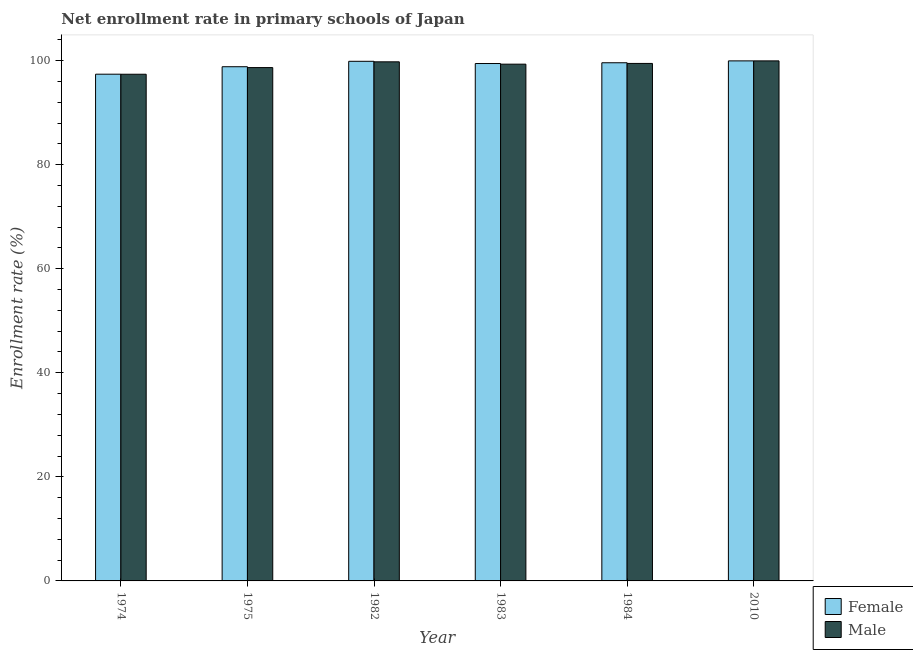How many different coloured bars are there?
Give a very brief answer. 2. How many groups of bars are there?
Ensure brevity in your answer.  6. Are the number of bars per tick equal to the number of legend labels?
Your answer should be very brief. Yes. Are the number of bars on each tick of the X-axis equal?
Your answer should be very brief. Yes. How many bars are there on the 2nd tick from the right?
Ensure brevity in your answer.  2. In how many cases, is the number of bars for a given year not equal to the number of legend labels?
Provide a short and direct response. 0. What is the enrollment rate of male students in 2010?
Your response must be concise. 99.95. Across all years, what is the maximum enrollment rate of female students?
Offer a very short reply. 99.95. Across all years, what is the minimum enrollment rate of male students?
Make the answer very short. 97.38. In which year was the enrollment rate of male students maximum?
Provide a short and direct response. 2010. In which year was the enrollment rate of female students minimum?
Offer a very short reply. 1974. What is the total enrollment rate of male students in the graph?
Make the answer very short. 594.53. What is the difference between the enrollment rate of female students in 1974 and that in 2010?
Your answer should be very brief. -2.56. What is the difference between the enrollment rate of female students in 1974 and the enrollment rate of male students in 1982?
Your answer should be compact. -2.48. What is the average enrollment rate of male students per year?
Give a very brief answer. 99.09. In the year 1983, what is the difference between the enrollment rate of male students and enrollment rate of female students?
Your response must be concise. 0. What is the ratio of the enrollment rate of male students in 1983 to that in 2010?
Give a very brief answer. 0.99. Is the enrollment rate of female students in 1982 less than that in 1984?
Your answer should be compact. No. What is the difference between the highest and the second highest enrollment rate of female students?
Keep it short and to the point. 0.08. What is the difference between the highest and the lowest enrollment rate of male students?
Make the answer very short. 2.57. In how many years, is the enrollment rate of female students greater than the average enrollment rate of female students taken over all years?
Offer a very short reply. 4. Is the sum of the enrollment rate of male students in 1975 and 1984 greater than the maximum enrollment rate of female students across all years?
Offer a terse response. Yes. What does the 2nd bar from the right in 1974 represents?
Your response must be concise. Female. Are all the bars in the graph horizontal?
Offer a very short reply. No. How many years are there in the graph?
Your answer should be compact. 6. What is the difference between two consecutive major ticks on the Y-axis?
Provide a succinct answer. 20. What is the title of the graph?
Your answer should be very brief. Net enrollment rate in primary schools of Japan. What is the label or title of the X-axis?
Your answer should be very brief. Year. What is the label or title of the Y-axis?
Make the answer very short. Enrollment rate (%). What is the Enrollment rate (%) in Female in 1974?
Your answer should be very brief. 97.39. What is the Enrollment rate (%) of Male in 1974?
Offer a very short reply. 97.38. What is the Enrollment rate (%) in Female in 1975?
Keep it short and to the point. 98.82. What is the Enrollment rate (%) of Male in 1975?
Give a very brief answer. 98.66. What is the Enrollment rate (%) of Female in 1982?
Give a very brief answer. 99.87. What is the Enrollment rate (%) in Male in 1982?
Provide a succinct answer. 99.77. What is the Enrollment rate (%) in Female in 1983?
Provide a succinct answer. 99.44. What is the Enrollment rate (%) in Male in 1983?
Offer a very short reply. 99.32. What is the Enrollment rate (%) in Female in 1984?
Your response must be concise. 99.59. What is the Enrollment rate (%) of Male in 1984?
Keep it short and to the point. 99.46. What is the Enrollment rate (%) in Female in 2010?
Provide a succinct answer. 99.95. What is the Enrollment rate (%) in Male in 2010?
Give a very brief answer. 99.95. Across all years, what is the maximum Enrollment rate (%) in Female?
Your answer should be very brief. 99.95. Across all years, what is the maximum Enrollment rate (%) of Male?
Your answer should be compact. 99.95. Across all years, what is the minimum Enrollment rate (%) of Female?
Make the answer very short. 97.39. Across all years, what is the minimum Enrollment rate (%) in Male?
Provide a short and direct response. 97.38. What is the total Enrollment rate (%) in Female in the graph?
Your response must be concise. 595.06. What is the total Enrollment rate (%) of Male in the graph?
Offer a terse response. 594.53. What is the difference between the Enrollment rate (%) in Female in 1974 and that in 1975?
Offer a very short reply. -1.43. What is the difference between the Enrollment rate (%) of Male in 1974 and that in 1975?
Provide a succinct answer. -1.28. What is the difference between the Enrollment rate (%) in Female in 1974 and that in 1982?
Provide a succinct answer. -2.48. What is the difference between the Enrollment rate (%) of Male in 1974 and that in 1982?
Offer a terse response. -2.39. What is the difference between the Enrollment rate (%) in Female in 1974 and that in 1983?
Offer a terse response. -2.05. What is the difference between the Enrollment rate (%) in Male in 1974 and that in 1983?
Offer a very short reply. -1.94. What is the difference between the Enrollment rate (%) of Female in 1974 and that in 1984?
Your response must be concise. -2.2. What is the difference between the Enrollment rate (%) in Male in 1974 and that in 1984?
Provide a short and direct response. -2.08. What is the difference between the Enrollment rate (%) of Female in 1974 and that in 2010?
Your response must be concise. -2.56. What is the difference between the Enrollment rate (%) of Male in 1974 and that in 2010?
Keep it short and to the point. -2.57. What is the difference between the Enrollment rate (%) of Female in 1975 and that in 1982?
Your response must be concise. -1.04. What is the difference between the Enrollment rate (%) in Male in 1975 and that in 1982?
Keep it short and to the point. -1.11. What is the difference between the Enrollment rate (%) of Female in 1975 and that in 1983?
Offer a terse response. -0.62. What is the difference between the Enrollment rate (%) in Male in 1975 and that in 1983?
Make the answer very short. -0.66. What is the difference between the Enrollment rate (%) in Female in 1975 and that in 1984?
Offer a terse response. -0.76. What is the difference between the Enrollment rate (%) in Male in 1975 and that in 1984?
Ensure brevity in your answer.  -0.8. What is the difference between the Enrollment rate (%) in Female in 1975 and that in 2010?
Keep it short and to the point. -1.13. What is the difference between the Enrollment rate (%) of Male in 1975 and that in 2010?
Give a very brief answer. -1.29. What is the difference between the Enrollment rate (%) of Female in 1982 and that in 1983?
Offer a terse response. 0.43. What is the difference between the Enrollment rate (%) of Male in 1982 and that in 1983?
Your answer should be very brief. 0.45. What is the difference between the Enrollment rate (%) in Female in 1982 and that in 1984?
Offer a terse response. 0.28. What is the difference between the Enrollment rate (%) of Male in 1982 and that in 1984?
Give a very brief answer. 0.31. What is the difference between the Enrollment rate (%) of Female in 1982 and that in 2010?
Provide a short and direct response. -0.08. What is the difference between the Enrollment rate (%) in Male in 1982 and that in 2010?
Offer a very short reply. -0.18. What is the difference between the Enrollment rate (%) of Female in 1983 and that in 1984?
Offer a terse response. -0.15. What is the difference between the Enrollment rate (%) in Male in 1983 and that in 1984?
Your answer should be compact. -0.14. What is the difference between the Enrollment rate (%) in Female in 1983 and that in 2010?
Provide a short and direct response. -0.51. What is the difference between the Enrollment rate (%) of Male in 1983 and that in 2010?
Give a very brief answer. -0.63. What is the difference between the Enrollment rate (%) of Female in 1984 and that in 2010?
Your response must be concise. -0.36. What is the difference between the Enrollment rate (%) in Male in 1984 and that in 2010?
Offer a terse response. -0.49. What is the difference between the Enrollment rate (%) in Female in 1974 and the Enrollment rate (%) in Male in 1975?
Your answer should be very brief. -1.27. What is the difference between the Enrollment rate (%) of Female in 1974 and the Enrollment rate (%) of Male in 1982?
Offer a very short reply. -2.38. What is the difference between the Enrollment rate (%) of Female in 1974 and the Enrollment rate (%) of Male in 1983?
Offer a terse response. -1.93. What is the difference between the Enrollment rate (%) of Female in 1974 and the Enrollment rate (%) of Male in 1984?
Your answer should be compact. -2.07. What is the difference between the Enrollment rate (%) of Female in 1974 and the Enrollment rate (%) of Male in 2010?
Offer a very short reply. -2.56. What is the difference between the Enrollment rate (%) in Female in 1975 and the Enrollment rate (%) in Male in 1982?
Ensure brevity in your answer.  -0.94. What is the difference between the Enrollment rate (%) of Female in 1975 and the Enrollment rate (%) of Male in 1983?
Ensure brevity in your answer.  -0.49. What is the difference between the Enrollment rate (%) of Female in 1975 and the Enrollment rate (%) of Male in 1984?
Your answer should be very brief. -0.63. What is the difference between the Enrollment rate (%) of Female in 1975 and the Enrollment rate (%) of Male in 2010?
Give a very brief answer. -1.13. What is the difference between the Enrollment rate (%) in Female in 1982 and the Enrollment rate (%) in Male in 1983?
Your answer should be very brief. 0.55. What is the difference between the Enrollment rate (%) in Female in 1982 and the Enrollment rate (%) in Male in 1984?
Provide a succinct answer. 0.41. What is the difference between the Enrollment rate (%) of Female in 1982 and the Enrollment rate (%) of Male in 2010?
Ensure brevity in your answer.  -0.08. What is the difference between the Enrollment rate (%) in Female in 1983 and the Enrollment rate (%) in Male in 1984?
Ensure brevity in your answer.  -0.02. What is the difference between the Enrollment rate (%) in Female in 1983 and the Enrollment rate (%) in Male in 2010?
Keep it short and to the point. -0.51. What is the difference between the Enrollment rate (%) in Female in 1984 and the Enrollment rate (%) in Male in 2010?
Offer a terse response. -0.36. What is the average Enrollment rate (%) of Female per year?
Provide a succinct answer. 99.18. What is the average Enrollment rate (%) of Male per year?
Ensure brevity in your answer.  99.09. In the year 1974, what is the difference between the Enrollment rate (%) in Female and Enrollment rate (%) in Male?
Provide a short and direct response. 0.01. In the year 1975, what is the difference between the Enrollment rate (%) of Female and Enrollment rate (%) of Male?
Provide a succinct answer. 0.16. In the year 1982, what is the difference between the Enrollment rate (%) of Female and Enrollment rate (%) of Male?
Provide a succinct answer. 0.1. In the year 1983, what is the difference between the Enrollment rate (%) of Female and Enrollment rate (%) of Male?
Give a very brief answer. 0.12. In the year 1984, what is the difference between the Enrollment rate (%) of Female and Enrollment rate (%) of Male?
Make the answer very short. 0.13. What is the ratio of the Enrollment rate (%) in Female in 1974 to that in 1975?
Your answer should be compact. 0.99. What is the ratio of the Enrollment rate (%) in Female in 1974 to that in 1982?
Your answer should be very brief. 0.98. What is the ratio of the Enrollment rate (%) of Male in 1974 to that in 1982?
Provide a succinct answer. 0.98. What is the ratio of the Enrollment rate (%) of Female in 1974 to that in 1983?
Keep it short and to the point. 0.98. What is the ratio of the Enrollment rate (%) of Male in 1974 to that in 1983?
Make the answer very short. 0.98. What is the ratio of the Enrollment rate (%) in Female in 1974 to that in 1984?
Your answer should be compact. 0.98. What is the ratio of the Enrollment rate (%) in Male in 1974 to that in 1984?
Give a very brief answer. 0.98. What is the ratio of the Enrollment rate (%) in Female in 1974 to that in 2010?
Offer a very short reply. 0.97. What is the ratio of the Enrollment rate (%) of Male in 1974 to that in 2010?
Provide a succinct answer. 0.97. What is the ratio of the Enrollment rate (%) in Female in 1975 to that in 1982?
Ensure brevity in your answer.  0.99. What is the ratio of the Enrollment rate (%) in Male in 1975 to that in 1982?
Provide a succinct answer. 0.99. What is the ratio of the Enrollment rate (%) of Female in 1975 to that in 1983?
Offer a very short reply. 0.99. What is the ratio of the Enrollment rate (%) of Female in 1975 to that in 1984?
Give a very brief answer. 0.99. What is the ratio of the Enrollment rate (%) of Female in 1975 to that in 2010?
Ensure brevity in your answer.  0.99. What is the ratio of the Enrollment rate (%) of Male in 1975 to that in 2010?
Give a very brief answer. 0.99. What is the ratio of the Enrollment rate (%) of Male in 1983 to that in 1984?
Keep it short and to the point. 1. What is the ratio of the Enrollment rate (%) in Female in 1984 to that in 2010?
Provide a short and direct response. 1. What is the ratio of the Enrollment rate (%) in Male in 1984 to that in 2010?
Provide a short and direct response. 1. What is the difference between the highest and the second highest Enrollment rate (%) in Female?
Your answer should be compact. 0.08. What is the difference between the highest and the second highest Enrollment rate (%) in Male?
Give a very brief answer. 0.18. What is the difference between the highest and the lowest Enrollment rate (%) of Female?
Your answer should be compact. 2.56. What is the difference between the highest and the lowest Enrollment rate (%) in Male?
Offer a very short reply. 2.57. 